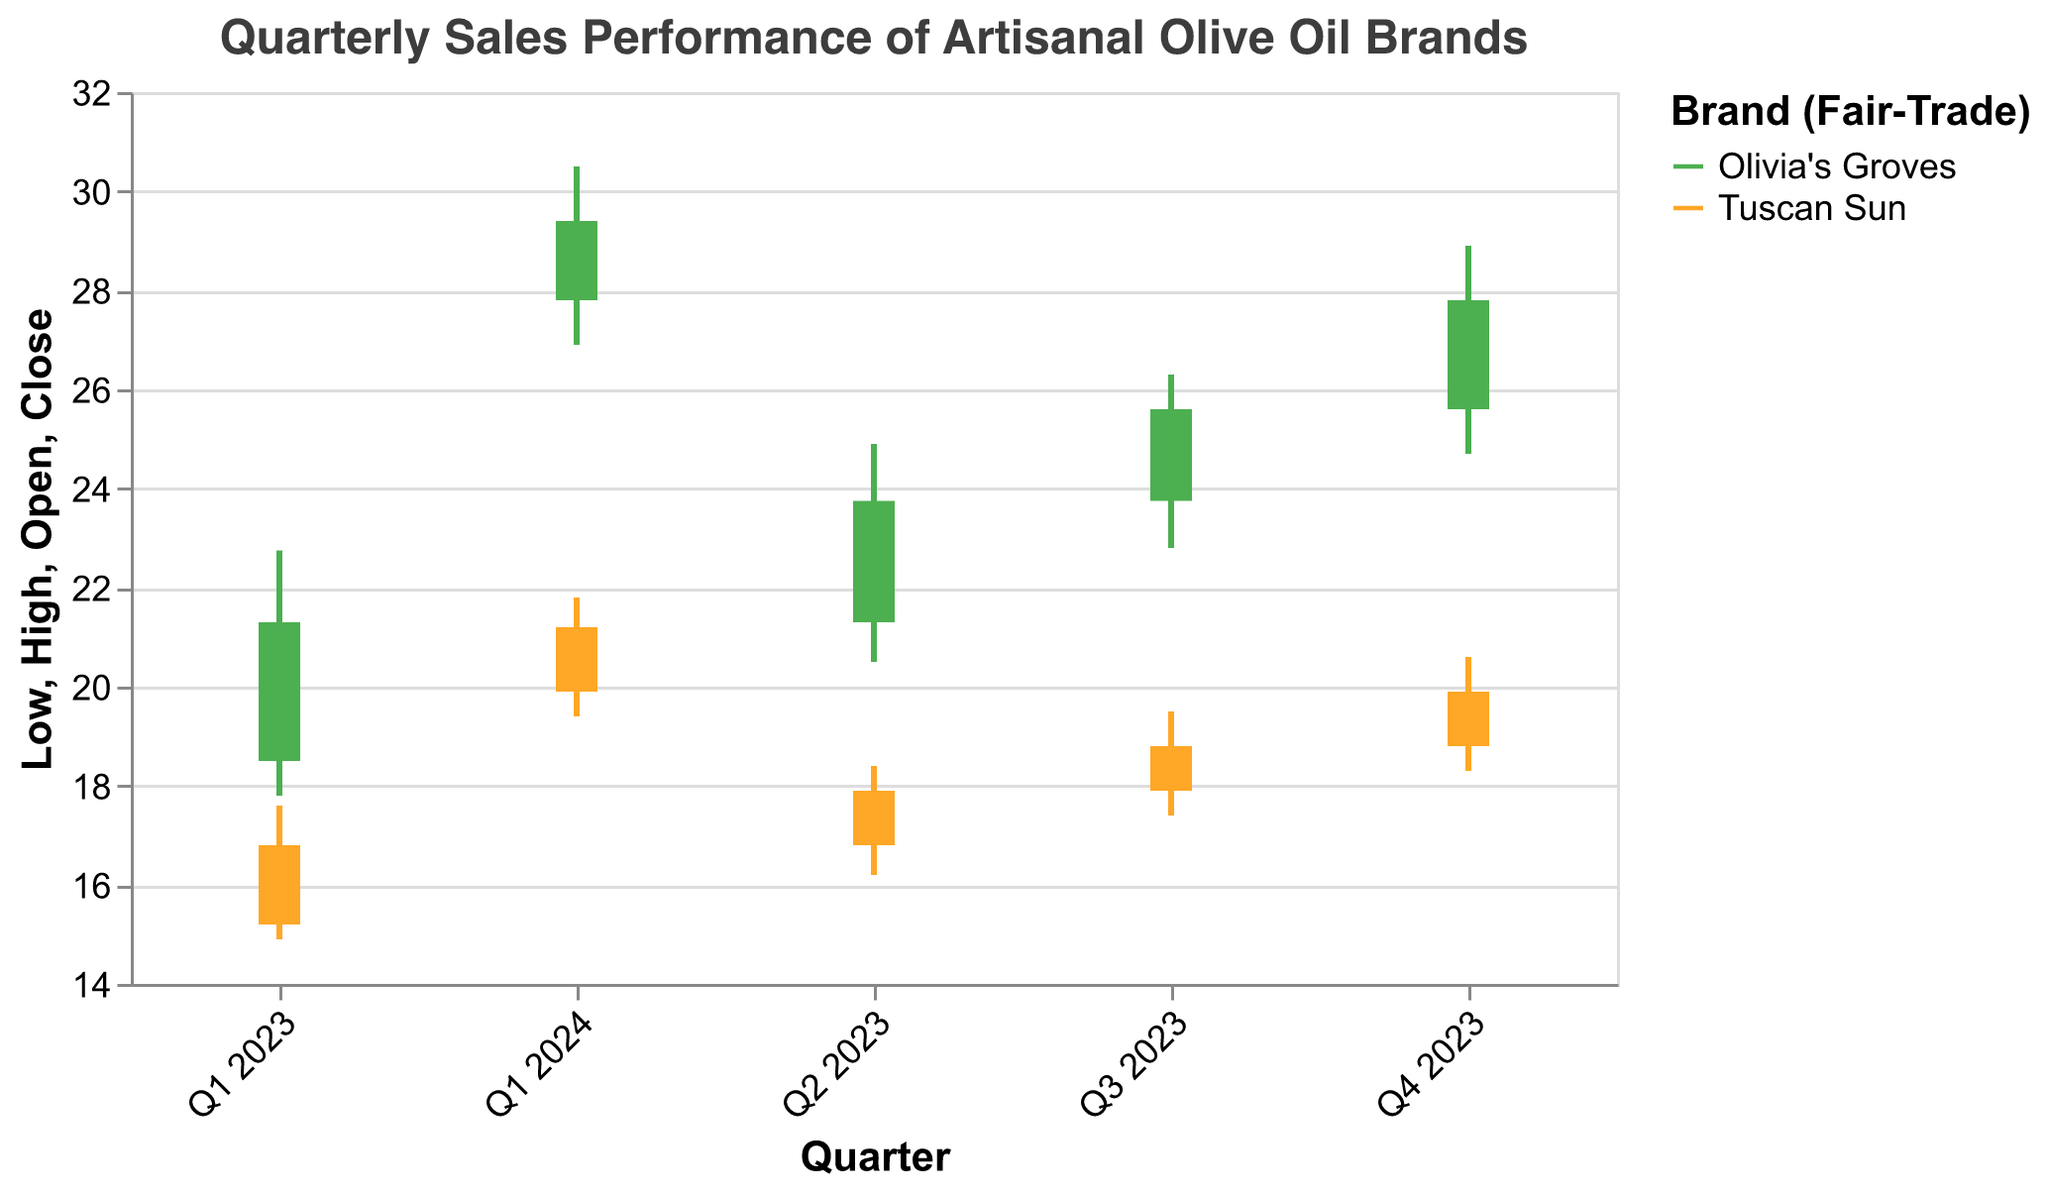What is the title of the figure? The title is placed at the top of the chart. It provides a summary of what the chart represents.
Answer: Quarterly Sales Performance of Artisanal Olive Oil Brands Which brand represents the fair-trade olive oil in the figure? The legend indicates that Olivia's Groves is identified with the color representing fair-trade.
Answer: Olivia's Groves What was the opening price of Tuscan Sun in Q3 2023? Locate Q3 2023 for Tuscan Sun and identify the bar's starting point.
Answer: 17.90 Which quarter had the highest closing price for Olivia's Groves? Identify the highest bar endpoint for Olivia's Groves across all quarters.
Answer: Q1 2024 What is the overall trend of Olivia's Groves' closing prices from Q1 2023 to Q1 2024? Observe the position of the bar endpoints for Olivia's Groves across the quarters.
Answer: Increasing How does the range of prices (High-Low) for Tuscan Sun compare between Q2 2023 and Q4 2023? Subtract the Low from the High for both quarters and compare the results. Q2 2023: 18.40 - 16.20 = 2.20, Q4 2023: 20.60 - 18.30 = 2.30.
Answer: The range in Q4 2023 is slightly larger Which brand had a higher closing price in Q4 2023? Compare the bar endpoints of both brands for Q4 2023.
Answer: Olivia's Groves What was the highest price point reached by Olivia's Groves in any quarter? Look for the highest point on the High parameter for Olivia's Groves.
Answer: 30.50 Did Tuscan Sun's closing price ever cross 20 units during the quarters shown? Check if the endpoints of Tuscan Sun's bars exceed 20 units.
Answer: Yes What is the difference in closing prices between Olivia's Groves and Tuscan Sun in Q1 2023? Subtract the closing price of Tuscan Sun from Olivia's Groves in Q1 2023. 21.30 - 16.80 = 4.50.
Answer: 4.50 